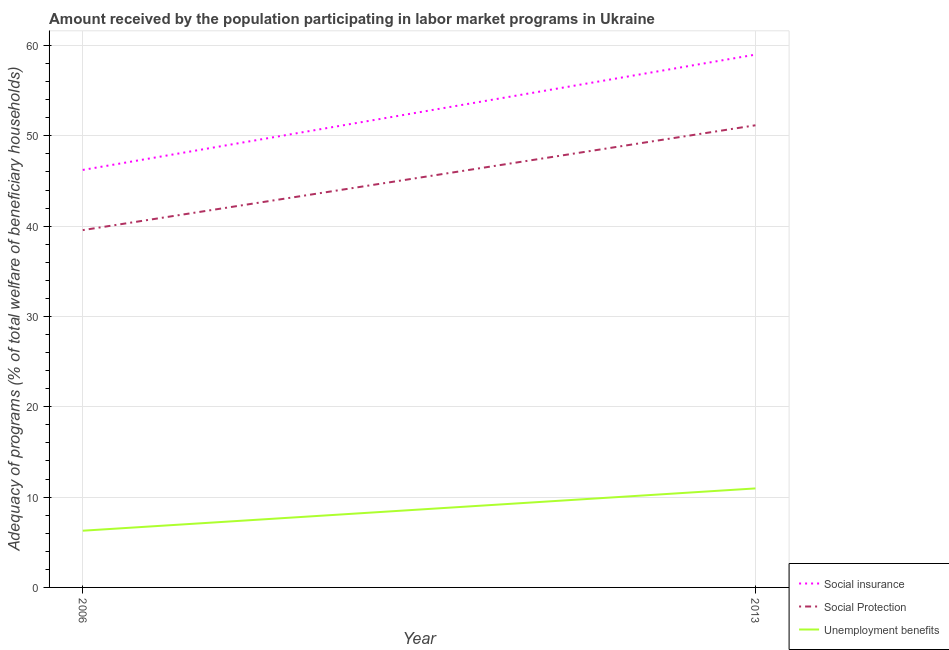How many different coloured lines are there?
Offer a very short reply. 3. Does the line corresponding to amount received by the population participating in social insurance programs intersect with the line corresponding to amount received by the population participating in unemployment benefits programs?
Ensure brevity in your answer.  No. Is the number of lines equal to the number of legend labels?
Your answer should be very brief. Yes. What is the amount received by the population participating in social insurance programs in 2006?
Your answer should be compact. 46.23. Across all years, what is the maximum amount received by the population participating in social protection programs?
Keep it short and to the point. 51.17. Across all years, what is the minimum amount received by the population participating in social insurance programs?
Make the answer very short. 46.23. In which year was the amount received by the population participating in social protection programs maximum?
Ensure brevity in your answer.  2013. In which year was the amount received by the population participating in social insurance programs minimum?
Your answer should be very brief. 2006. What is the total amount received by the population participating in social protection programs in the graph?
Offer a very short reply. 90.73. What is the difference between the amount received by the population participating in social insurance programs in 2006 and that in 2013?
Your response must be concise. -12.77. What is the difference between the amount received by the population participating in social protection programs in 2013 and the amount received by the population participating in social insurance programs in 2006?
Offer a terse response. 4.94. What is the average amount received by the population participating in unemployment benefits programs per year?
Your answer should be compact. 8.62. In the year 2006, what is the difference between the amount received by the population participating in social protection programs and amount received by the population participating in unemployment benefits programs?
Your response must be concise. 33.28. What is the ratio of the amount received by the population participating in social insurance programs in 2006 to that in 2013?
Make the answer very short. 0.78. In how many years, is the amount received by the population participating in social protection programs greater than the average amount received by the population participating in social protection programs taken over all years?
Your answer should be very brief. 1. Is the amount received by the population participating in unemployment benefits programs strictly less than the amount received by the population participating in social insurance programs over the years?
Make the answer very short. Yes. How many lines are there?
Offer a terse response. 3. What is the difference between two consecutive major ticks on the Y-axis?
Offer a terse response. 10. Does the graph contain any zero values?
Ensure brevity in your answer.  No. Does the graph contain grids?
Provide a succinct answer. Yes. How many legend labels are there?
Provide a short and direct response. 3. What is the title of the graph?
Offer a terse response. Amount received by the population participating in labor market programs in Ukraine. Does "Textiles and clothing" appear as one of the legend labels in the graph?
Provide a succinct answer. No. What is the label or title of the X-axis?
Make the answer very short. Year. What is the label or title of the Y-axis?
Your response must be concise. Adequacy of programs (% of total welfare of beneficiary households). What is the Adequacy of programs (% of total welfare of beneficiary households) in Social insurance in 2006?
Provide a succinct answer. 46.23. What is the Adequacy of programs (% of total welfare of beneficiary households) in Social Protection in 2006?
Provide a succinct answer. 39.56. What is the Adequacy of programs (% of total welfare of beneficiary households) in Unemployment benefits in 2006?
Give a very brief answer. 6.28. What is the Adequacy of programs (% of total welfare of beneficiary households) of Social insurance in 2013?
Offer a terse response. 58.99. What is the Adequacy of programs (% of total welfare of beneficiary households) in Social Protection in 2013?
Your response must be concise. 51.17. What is the Adequacy of programs (% of total welfare of beneficiary households) of Unemployment benefits in 2013?
Provide a short and direct response. 10.96. Across all years, what is the maximum Adequacy of programs (% of total welfare of beneficiary households) in Social insurance?
Provide a succinct answer. 58.99. Across all years, what is the maximum Adequacy of programs (% of total welfare of beneficiary households) in Social Protection?
Make the answer very short. 51.17. Across all years, what is the maximum Adequacy of programs (% of total welfare of beneficiary households) of Unemployment benefits?
Your answer should be compact. 10.96. Across all years, what is the minimum Adequacy of programs (% of total welfare of beneficiary households) of Social insurance?
Your answer should be very brief. 46.23. Across all years, what is the minimum Adequacy of programs (% of total welfare of beneficiary households) of Social Protection?
Give a very brief answer. 39.56. Across all years, what is the minimum Adequacy of programs (% of total welfare of beneficiary households) of Unemployment benefits?
Give a very brief answer. 6.28. What is the total Adequacy of programs (% of total welfare of beneficiary households) of Social insurance in the graph?
Give a very brief answer. 105.22. What is the total Adequacy of programs (% of total welfare of beneficiary households) in Social Protection in the graph?
Provide a succinct answer. 90.73. What is the total Adequacy of programs (% of total welfare of beneficiary households) in Unemployment benefits in the graph?
Make the answer very short. 17.24. What is the difference between the Adequacy of programs (% of total welfare of beneficiary households) in Social insurance in 2006 and that in 2013?
Ensure brevity in your answer.  -12.77. What is the difference between the Adequacy of programs (% of total welfare of beneficiary households) in Social Protection in 2006 and that in 2013?
Ensure brevity in your answer.  -11.61. What is the difference between the Adequacy of programs (% of total welfare of beneficiary households) of Unemployment benefits in 2006 and that in 2013?
Offer a terse response. -4.68. What is the difference between the Adequacy of programs (% of total welfare of beneficiary households) of Social insurance in 2006 and the Adequacy of programs (% of total welfare of beneficiary households) of Social Protection in 2013?
Your response must be concise. -4.94. What is the difference between the Adequacy of programs (% of total welfare of beneficiary households) in Social insurance in 2006 and the Adequacy of programs (% of total welfare of beneficiary households) in Unemployment benefits in 2013?
Your answer should be compact. 35.26. What is the difference between the Adequacy of programs (% of total welfare of beneficiary households) of Social Protection in 2006 and the Adequacy of programs (% of total welfare of beneficiary households) of Unemployment benefits in 2013?
Offer a very short reply. 28.6. What is the average Adequacy of programs (% of total welfare of beneficiary households) in Social insurance per year?
Provide a succinct answer. 52.61. What is the average Adequacy of programs (% of total welfare of beneficiary households) in Social Protection per year?
Give a very brief answer. 45.37. What is the average Adequacy of programs (% of total welfare of beneficiary households) of Unemployment benefits per year?
Ensure brevity in your answer.  8.62. In the year 2006, what is the difference between the Adequacy of programs (% of total welfare of beneficiary households) of Social insurance and Adequacy of programs (% of total welfare of beneficiary households) of Social Protection?
Offer a very short reply. 6.66. In the year 2006, what is the difference between the Adequacy of programs (% of total welfare of beneficiary households) in Social insurance and Adequacy of programs (% of total welfare of beneficiary households) in Unemployment benefits?
Offer a very short reply. 39.95. In the year 2006, what is the difference between the Adequacy of programs (% of total welfare of beneficiary households) in Social Protection and Adequacy of programs (% of total welfare of beneficiary households) in Unemployment benefits?
Give a very brief answer. 33.28. In the year 2013, what is the difference between the Adequacy of programs (% of total welfare of beneficiary households) in Social insurance and Adequacy of programs (% of total welfare of beneficiary households) in Social Protection?
Your response must be concise. 7.82. In the year 2013, what is the difference between the Adequacy of programs (% of total welfare of beneficiary households) in Social insurance and Adequacy of programs (% of total welfare of beneficiary households) in Unemployment benefits?
Make the answer very short. 48.03. In the year 2013, what is the difference between the Adequacy of programs (% of total welfare of beneficiary households) of Social Protection and Adequacy of programs (% of total welfare of beneficiary households) of Unemployment benefits?
Your answer should be very brief. 40.21. What is the ratio of the Adequacy of programs (% of total welfare of beneficiary households) in Social insurance in 2006 to that in 2013?
Your answer should be compact. 0.78. What is the ratio of the Adequacy of programs (% of total welfare of beneficiary households) of Social Protection in 2006 to that in 2013?
Your answer should be compact. 0.77. What is the ratio of the Adequacy of programs (% of total welfare of beneficiary households) of Unemployment benefits in 2006 to that in 2013?
Offer a very short reply. 0.57. What is the difference between the highest and the second highest Adequacy of programs (% of total welfare of beneficiary households) in Social insurance?
Keep it short and to the point. 12.77. What is the difference between the highest and the second highest Adequacy of programs (% of total welfare of beneficiary households) in Social Protection?
Provide a succinct answer. 11.61. What is the difference between the highest and the second highest Adequacy of programs (% of total welfare of beneficiary households) in Unemployment benefits?
Give a very brief answer. 4.68. What is the difference between the highest and the lowest Adequacy of programs (% of total welfare of beneficiary households) in Social insurance?
Provide a short and direct response. 12.77. What is the difference between the highest and the lowest Adequacy of programs (% of total welfare of beneficiary households) of Social Protection?
Offer a terse response. 11.61. What is the difference between the highest and the lowest Adequacy of programs (% of total welfare of beneficiary households) of Unemployment benefits?
Make the answer very short. 4.68. 